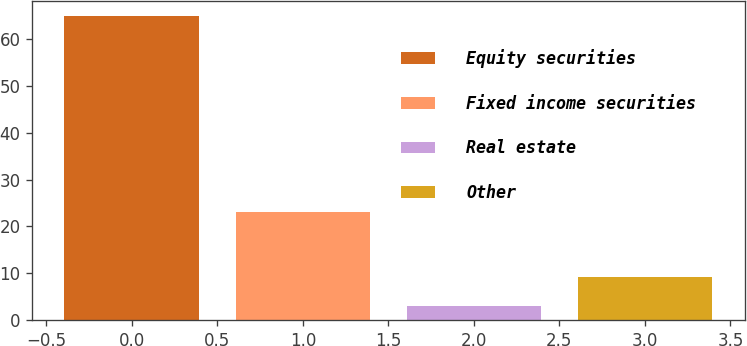<chart> <loc_0><loc_0><loc_500><loc_500><bar_chart><fcel>Equity securities<fcel>Fixed income securities<fcel>Real estate<fcel>Other<nl><fcel>65<fcel>23<fcel>3<fcel>9.2<nl></chart> 